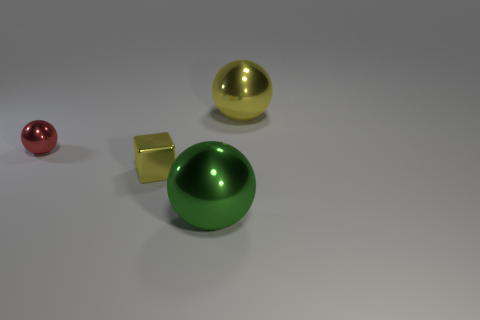What number of yellow cylinders have the same size as the green thing?
Provide a succinct answer. 0. What material is the large sphere that is right of the green metal thing?
Ensure brevity in your answer.  Metal. How many small red objects are the same shape as the big green metallic object?
Ensure brevity in your answer.  1. What is the shape of the small red object that is made of the same material as the small yellow object?
Keep it short and to the point. Sphere. What is the shape of the yellow shiny object on the left side of the yellow metallic thing on the right side of the large ball in front of the yellow cube?
Your response must be concise. Cube. Is the number of gray spheres greater than the number of tiny yellow things?
Your answer should be compact. No. There is a large yellow thing that is the same shape as the red shiny object; what is its material?
Give a very brief answer. Metal. Is the material of the green object the same as the yellow cube?
Provide a succinct answer. Yes. Are there more shiny objects that are on the left side of the big green sphere than big shiny balls?
Keep it short and to the point. No. What material is the yellow object that is to the left of the big shiny sphere that is on the left side of the large metallic sphere that is behind the tiny yellow shiny block?
Provide a short and direct response. Metal. 